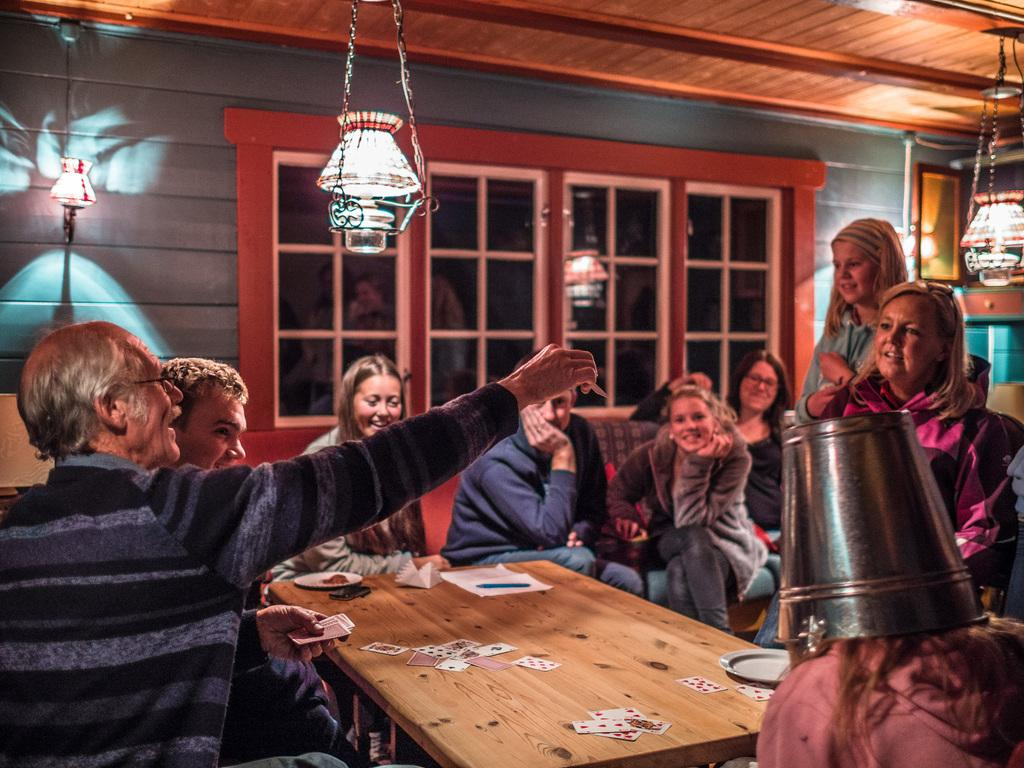What activity are the people in the image engaged in? The people in the image are playing cards. How are the card players positioned in the image? The people playing cards are sitting around a table. Are there any other people present in the image? Yes, there are other people watching the card game. How are the watchers positioned in relation to the table? The watchers are sitting beside the table. What time does the crib appear in the image? There is no crib present in the image. How does the spark affect the card game in the image? There is no spark present in the image, so it cannot affect the card game. 